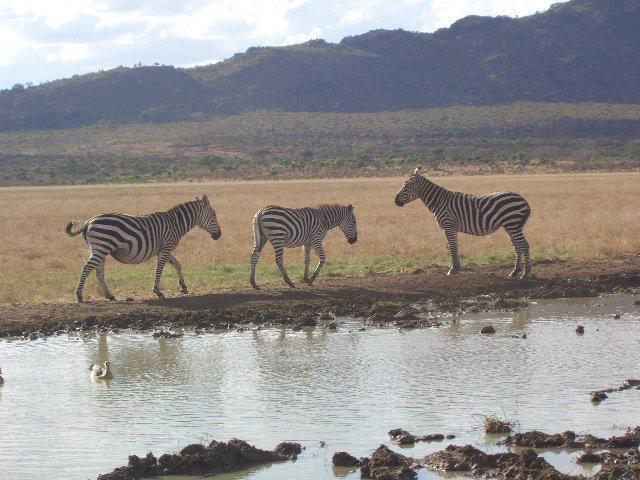What other animal is in the picture?
Quick response, please. Bird. What time of day is it?
Keep it brief. Midday. How many zebras are next to the water?
Give a very brief answer. 3. 